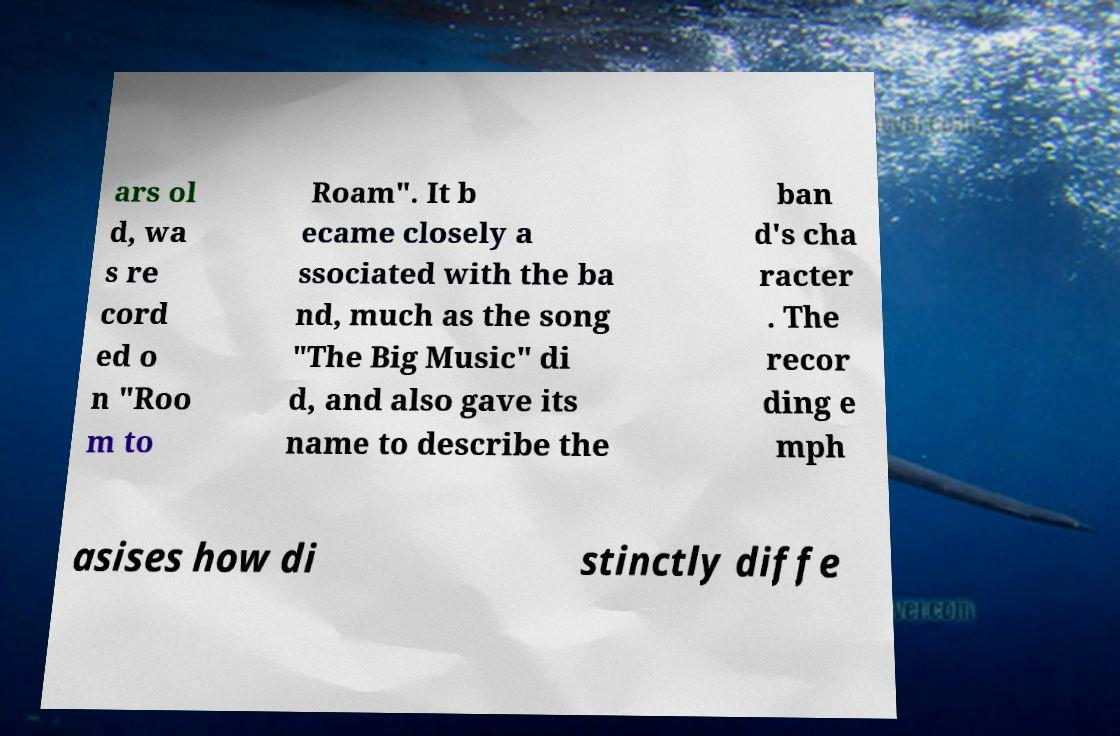I need the written content from this picture converted into text. Can you do that? ars ol d, wa s re cord ed o n "Roo m to Roam". It b ecame closely a ssociated with the ba nd, much as the song "The Big Music" di d, and also gave its name to describe the ban d's cha racter . The recor ding e mph asises how di stinctly diffe 